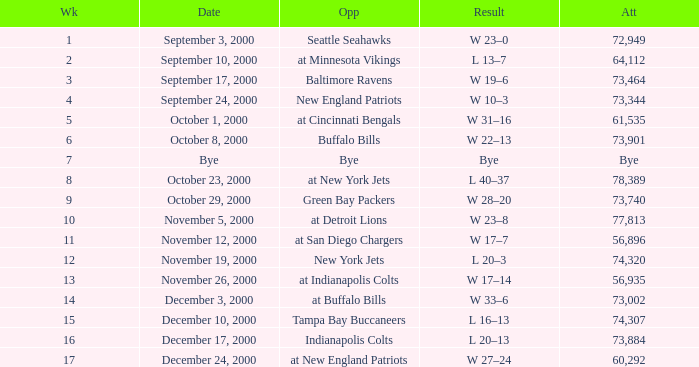What is the Attendance for a Week earlier than 16, and a Date of bye? Bye. 